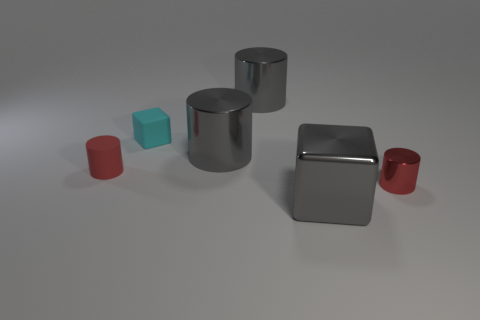What number of green objects are large shiny things or metal cylinders?
Provide a succinct answer. 0. Are there more metallic blocks on the left side of the small matte cube than big blocks?
Provide a short and direct response. No. Is there a large metal cylinder of the same color as the large cube?
Ensure brevity in your answer.  Yes. The cyan rubber thing has what size?
Offer a very short reply. Small. Does the large cube have the same color as the matte block?
Your answer should be compact. No. How many things are metallic things or tiny red things on the left side of the small cyan object?
Give a very brief answer. 5. How many metal cylinders are behind the big gray metallic thing that is in front of the small red thing right of the tiny block?
Your answer should be very brief. 3. What is the material of the other thing that is the same color as the tiny shiny object?
Your answer should be very brief. Rubber. How many tiny cylinders are there?
Provide a succinct answer. 2. There is a gray object that is behind the cyan rubber block; is its size the same as the tiny matte cube?
Provide a succinct answer. No. 